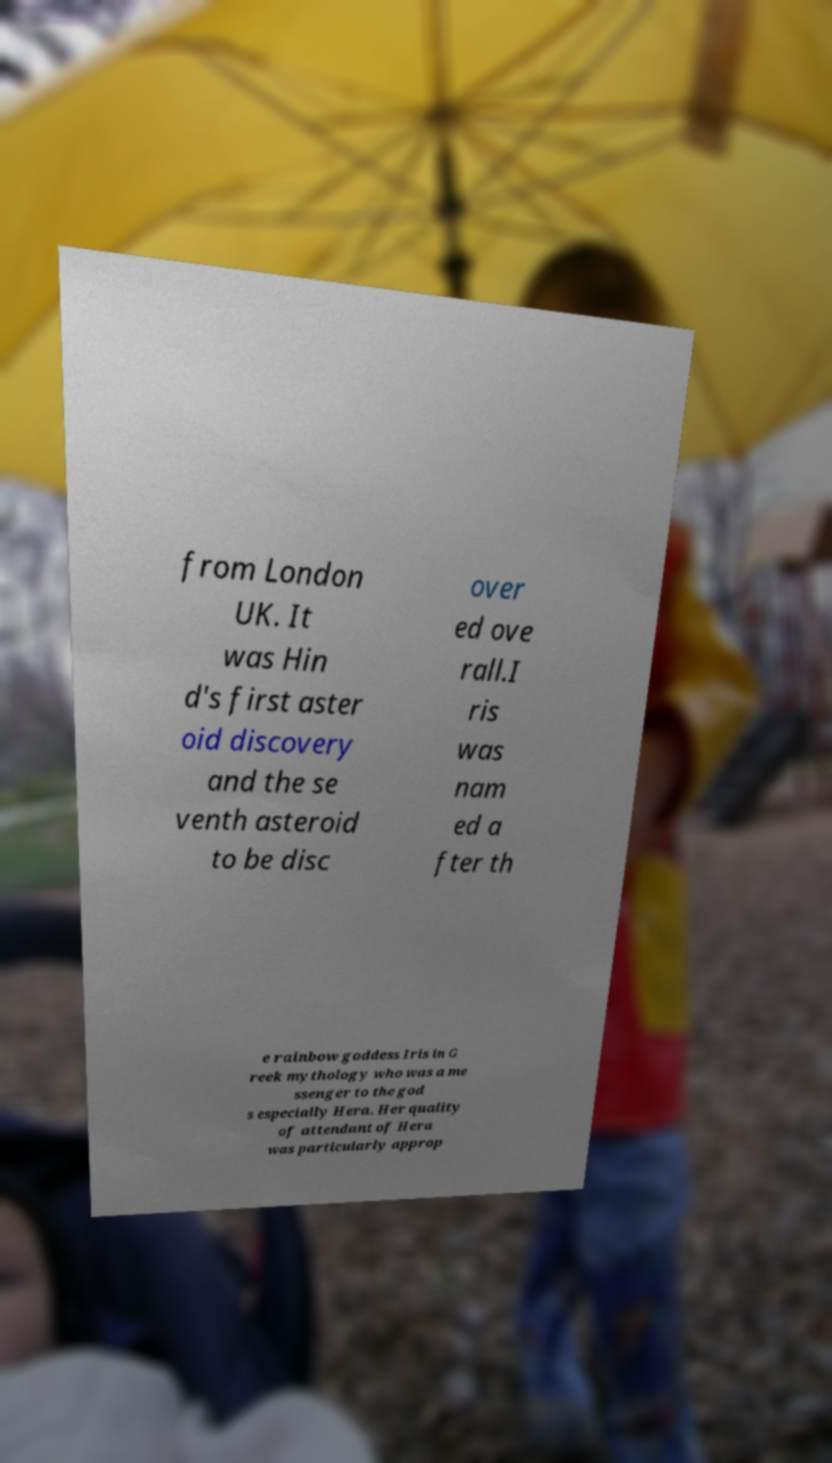Can you read and provide the text displayed in the image?This photo seems to have some interesting text. Can you extract and type it out for me? from London UK. It was Hin d's first aster oid discovery and the se venth asteroid to be disc over ed ove rall.I ris was nam ed a fter th e rainbow goddess Iris in G reek mythology who was a me ssenger to the god s especially Hera. Her quality of attendant of Hera was particularly approp 